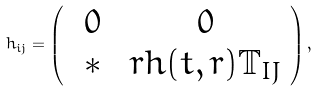<formula> <loc_0><loc_0><loc_500><loc_500>h _ { i j } = \left ( \begin{array} { c c } \ 0 \ & \ 0 \ \\ * & r h ( t , r ) \mathbb { T } _ { I J } \end{array} \right ) ,</formula> 